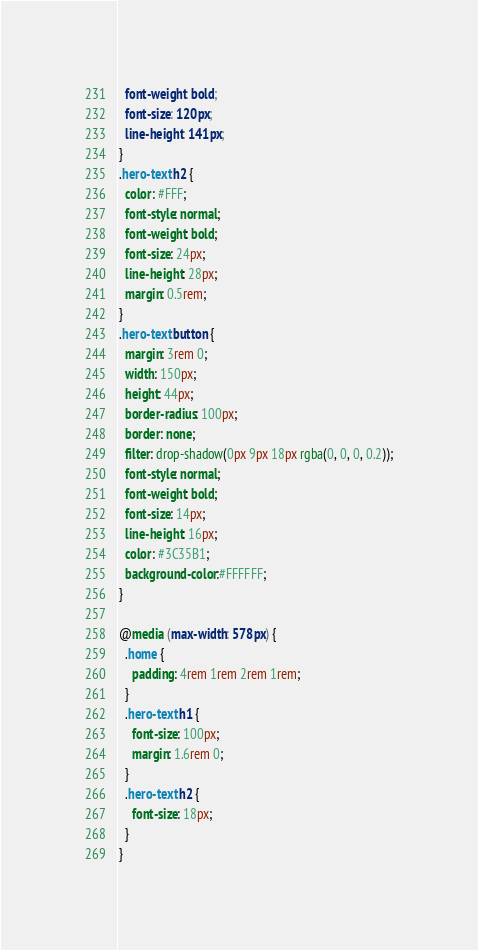<code> <loc_0><loc_0><loc_500><loc_500><_CSS_>  font-weight: bold;
  font-size: 120px;
  line-height: 141px;
}
.hero-text h2 {
  color: #FFF;
  font-style: normal;
  font-weight: bold;
  font-size: 24px;
  line-height: 28px;  
  margin: 0.5rem;
}
.hero-text button {
  margin: 3rem 0;
  width: 150px;
  height: 44px;
  border-radius: 100px;
  border: none;
  filter: drop-shadow(0px 9px 18px rgba(0, 0, 0, 0.2));
  font-style: normal;
  font-weight: bold;
  font-size: 14px;
  line-height: 16px;
  color: #3C35B1;
  background-color:#FFFFFF;
}

@media (max-width: 578px) {
  .home {
    padding: 4rem 1rem 2rem 1rem;
  }
  .hero-text h1 {
    font-size: 100px;
    margin: 1.6rem 0;
  }
  .hero-text h2 {
    font-size: 18px;
  }
}

</code> 